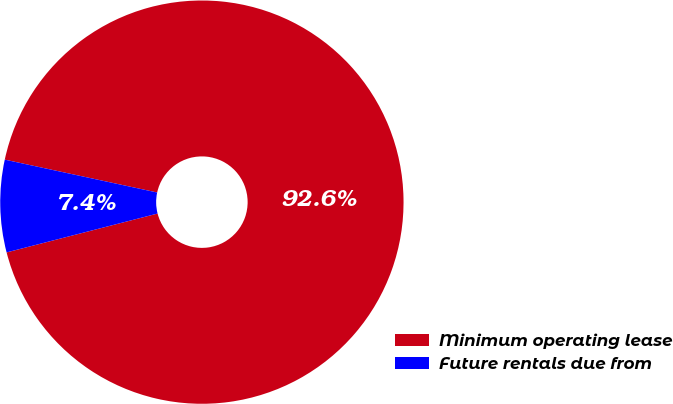Convert chart. <chart><loc_0><loc_0><loc_500><loc_500><pie_chart><fcel>Minimum operating lease<fcel>Future rentals due from<nl><fcel>92.61%<fcel>7.39%<nl></chart> 